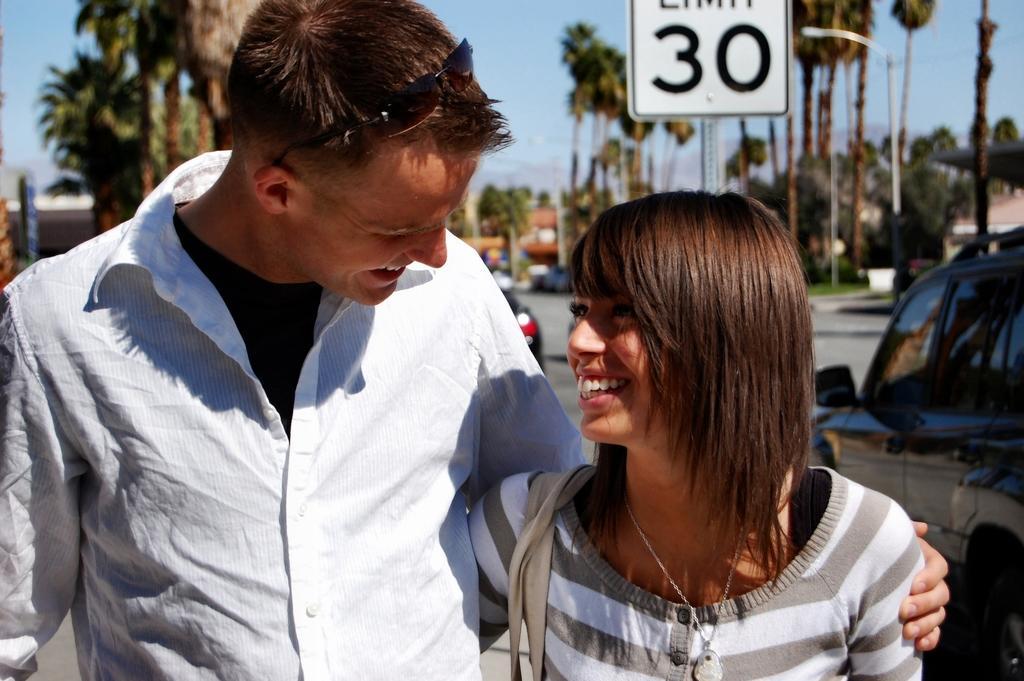How would you summarize this image in a sentence or two? In this image in the front there are persons standing and smiling. In the background there are trees, vehicles and there is grass on the ground and there is a pole with some number written on it and there are buildings. 